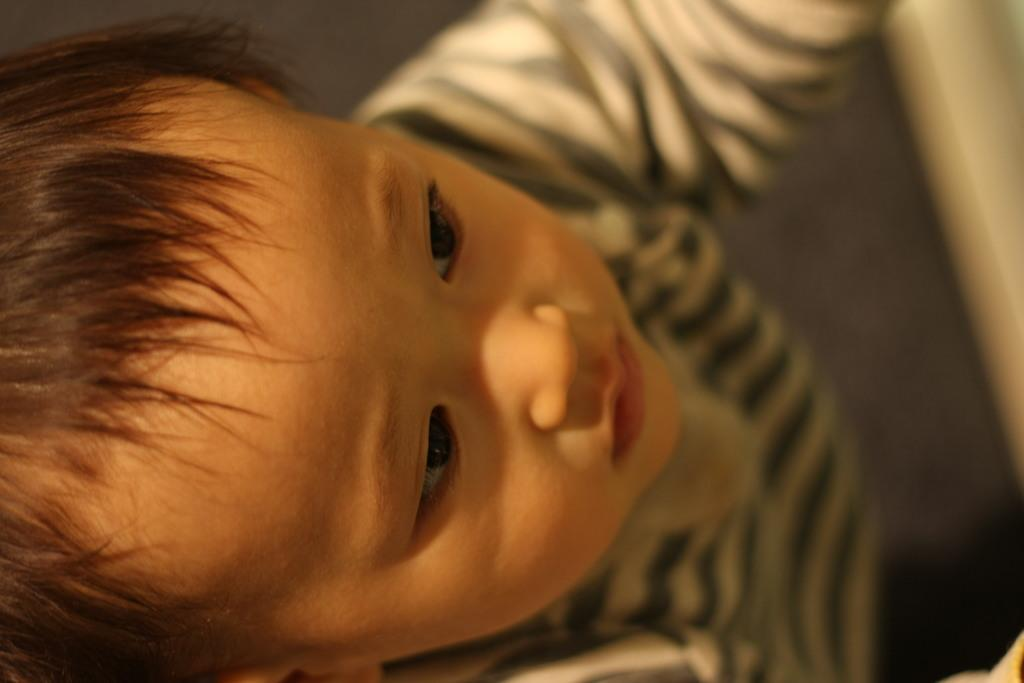What is the main subject of the image? The main subject of the image is a kid. What type of fruit can be seen growing on the land in the image? There is no fruit or land present in the image; it only features a kid. 